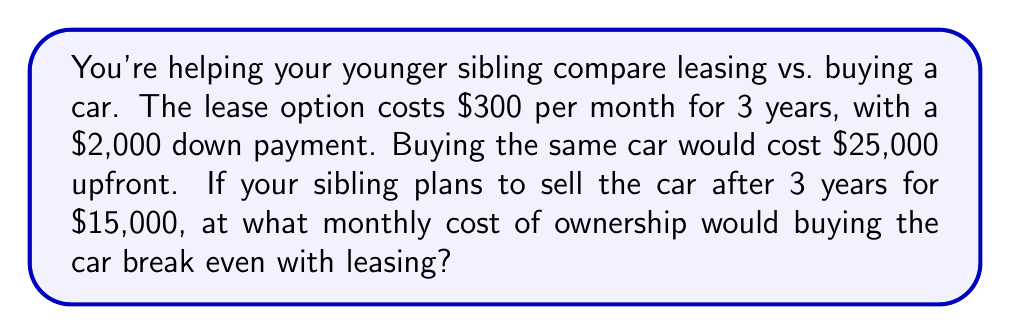Can you solve this math problem? Let's approach this step-by-step:

1) First, calculate the total cost of leasing:
   Down payment + (Monthly payment × Number of months)
   $$ 2,000 + (300 × 36) = 2,000 + 10,800 = $12,800 $$

2) For buying, we need to consider the initial cost and the resale value:
   Cost of buying - Resale value = Net cost of ownership
   $$ 25,000 - 15,000 = $10,000 $$

3) To break even, the net cost of ownership should equal the total cost of leasing:
   $$ 10,000 + \text{Additional ownership costs} = 12,800 $$
   $$ \text{Additional ownership costs} = 12,800 - 10,000 = $2,800 $$

4) This $2,800 represents the additional costs over 3 years (36 months) that would make buying equal to leasing. To find the monthly cost:
   $$ \text{Monthly additional cost} = \frac{2,800}{36} = $77.78 \text{ per month} $$

Therefore, if the monthly cost of ownership (including maintenance, insurance difference, etc.) is $77.78, buying would break even with leasing after 3 years.
Answer: $77.78 per month 